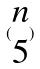<formula> <loc_0><loc_0><loc_500><loc_500>( \begin{matrix} n \\ 5 \end{matrix} )</formula> 